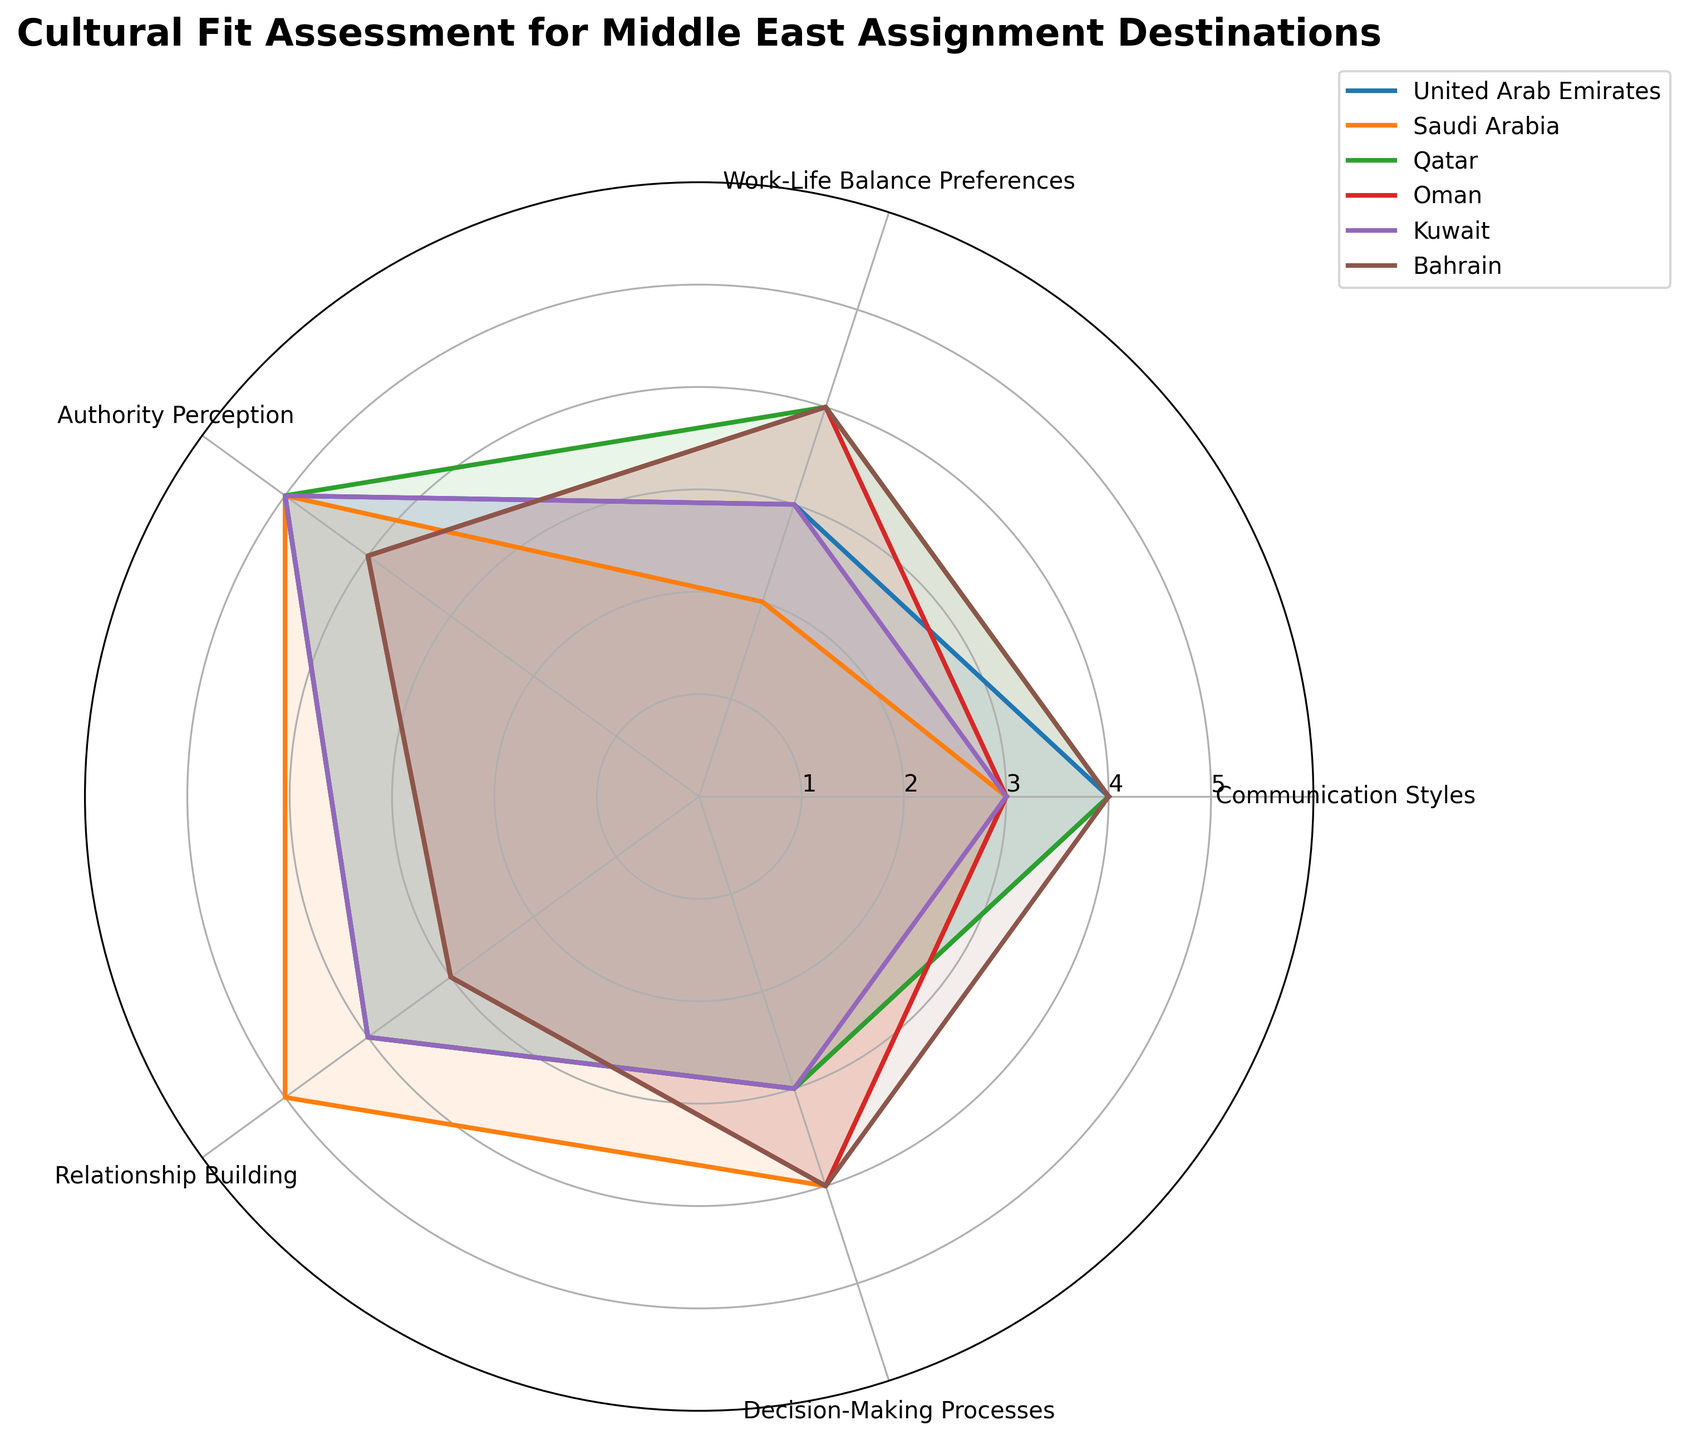What is the title of the radar chart? The title is displayed at the top of the radar chart using a bold font. The text reads as "Cultural Fit Assessment for Middle East Assignment Destinations".
Answer: Cultural Fit Assessment for Middle East Assignment Destinations How many countries are being compared in the radar chart? The radar chart has a legend on the right side that lists the countries being compared. The countries are United Arab Emirates, Saudi Arabia, Qatar, Oman, Kuwait, and Bahrain. Counting these countries gives a total of six.
Answer: Six Which country has the highest value for Relationship Building? To determine this, look at the points corresponding to the Relationship Building axis for each country. The highest value point in this category belongs to Saudi Arabia.
Answer: Saudi Arabia What is the average score for Work-Life Balance Preferences across all the countries? First, extract the Work-Life Balance Preferences scores for all countries: UAE (3), Saudi Arabia (2), Qatar (4), Oman (4), Kuwait (3), and Bahrain (4). Summing these scores: 3 + 2 + 4 + 4 + 3 + 4 = 20. Divide by the number of countries, which is 6. The average is 20/6 ≈ 3.33.
Answer: 3.33 Which two countries have the same score for Decision-Making Processes? Check the Decision-Making Processes axis points for each country in the radar chart. Qatar and the United Arab Emirates both score a 3 in Decision-Making Processes.
Answer: Qatar and United Arab Emirates How does United Arab Emirates compare to Oman in Authority Perception? On the axis representing Authority Perception, track the scores for UAE and Oman. UAE scores 5, while Oman scores 4. This means UAE has a higher score than Oman in Authority Perception.
Answer: UAE has a higher score Which country has a balanced score across all categories? A balanced score means the values are quite close to each other across the different categories. Bahrain has scores of 4, 4, 4, 3, and 4. This suggests Bahrain has a balanced distribution across the categories compared to other countries with more varied scores.
Answer: Bahrain What is the difference in Communication Styles score between Qatar and Saudi Arabia? Look at the Communication Styles scores for Qatar (4) and Saudi Arabia (3). Subtract the Saudi Arabia score from the Qatar score: 4 - 3 = 1.
Answer: 1 What range of values is used for the assessment scores in the radar chart? The radial lines on the chart are labeled with values from 1 to 5, indicating the assessment scores range from 1 to 5.
Answer: 1 to 5 Which country has the highest combined score for Relationship Building and Decision-Making Processes? Calculate the sum of the scores for Relationship Building and Decision-Making Processes for each country. The highest sum is for Saudi Arabia with scores of 5 (Relationship Building) and 4 (Decision-Making Processes), totaling 9.
Answer: Saudi Arabia 